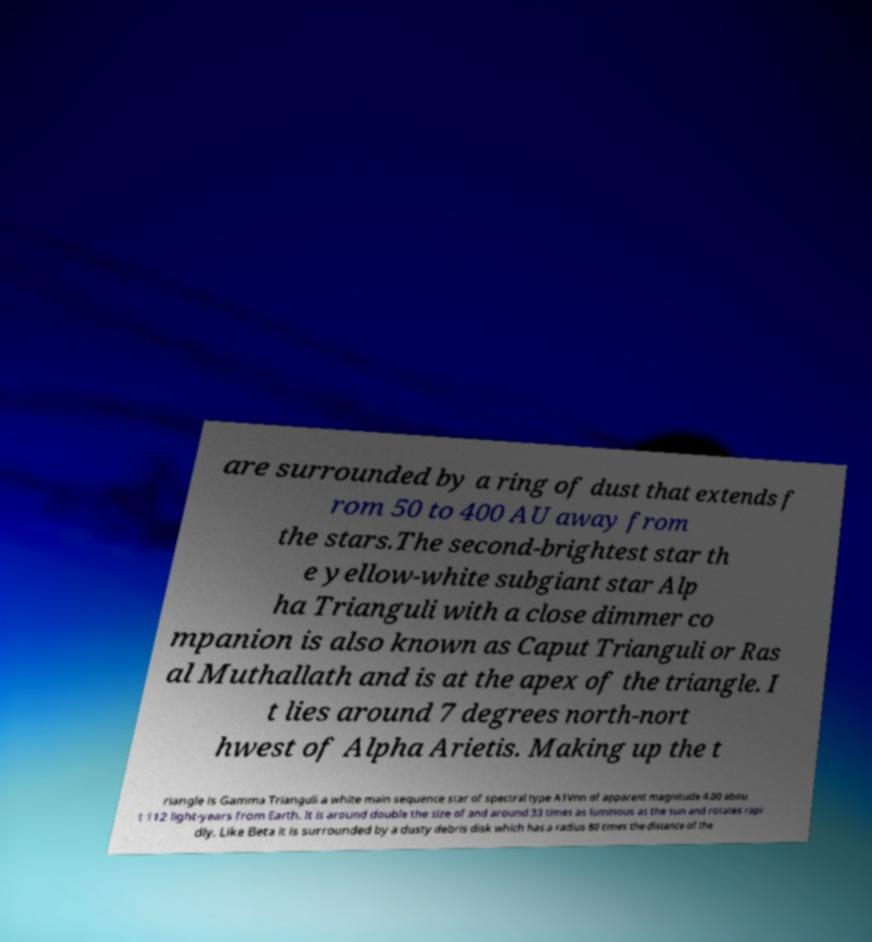There's text embedded in this image that I need extracted. Can you transcribe it verbatim? are surrounded by a ring of dust that extends f rom 50 to 400 AU away from the stars.The second-brightest star th e yellow-white subgiant star Alp ha Trianguli with a close dimmer co mpanion is also known as Caput Trianguli or Ras al Muthallath and is at the apex of the triangle. I t lies around 7 degrees north-nort hwest of Alpha Arietis. Making up the t riangle is Gamma Trianguli a white main sequence star of spectral type A1Vnn of apparent magnitude 4.00 abou t 112 light-years from Earth. It is around double the size of and around 33 times as luminous as the sun and rotates rapi dly. Like Beta it is surrounded by a dusty debris disk which has a radius 80 times the distance of the 